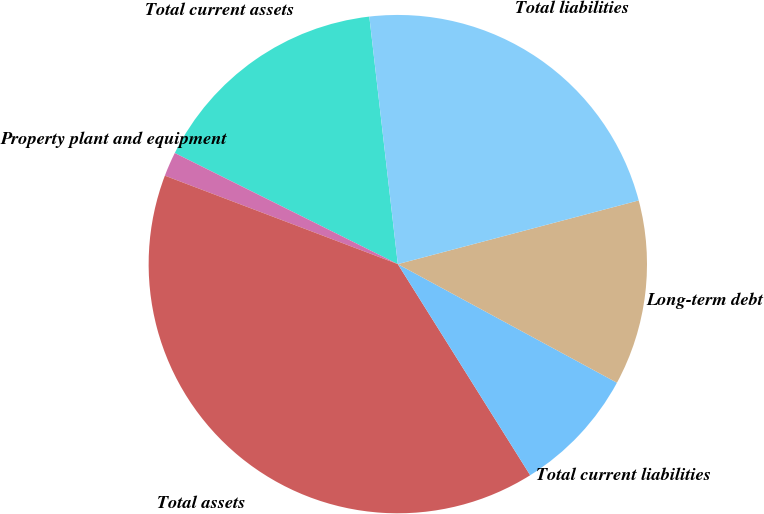Convert chart. <chart><loc_0><loc_0><loc_500><loc_500><pie_chart><fcel>Total current assets<fcel>Property plant and equipment<fcel>Total assets<fcel>Total current liabilities<fcel>Long-term debt<fcel>Total liabilities<nl><fcel>15.82%<fcel>1.58%<fcel>39.69%<fcel>8.19%<fcel>12.01%<fcel>22.71%<nl></chart> 